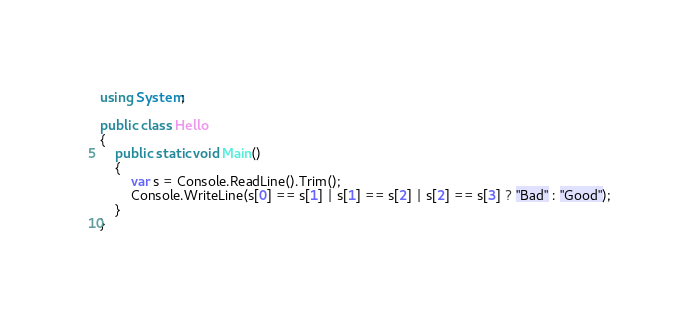<code> <loc_0><loc_0><loc_500><loc_500><_C#_>using System;

public class Hello
{
	public static void Main()
	{
		var s = Console.ReadLine().Trim();
		Console.WriteLine(s[0] == s[1] | s[1] == s[2] | s[2] == s[3] ? "Bad" : "Good");
	}
}</code> 